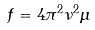Convert formula to latex. <formula><loc_0><loc_0><loc_500><loc_500>f = 4 \pi ^ { 2 } \nu ^ { 2 } \mu</formula> 